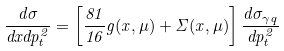Convert formula to latex. <formula><loc_0><loc_0><loc_500><loc_500>\frac { d \sigma } { d x d p _ { t } ^ { 2 } } = \left [ \frac { 8 1 } { 1 6 } g ( x , \mu ) + \Sigma ( x , \mu ) \right ] \frac { d \sigma _ { \gamma q } } { d p _ { t } ^ { 2 } }</formula> 